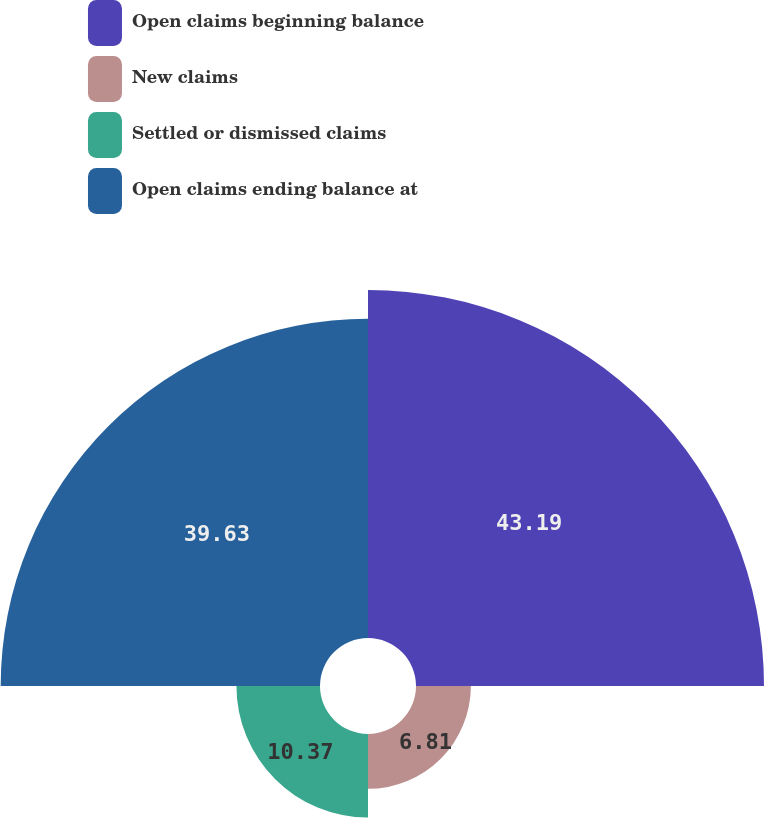Convert chart to OTSL. <chart><loc_0><loc_0><loc_500><loc_500><pie_chart><fcel>Open claims beginning balance<fcel>New claims<fcel>Settled or dismissed claims<fcel>Open claims ending balance at<nl><fcel>43.19%<fcel>6.81%<fcel>10.37%<fcel>39.63%<nl></chart> 